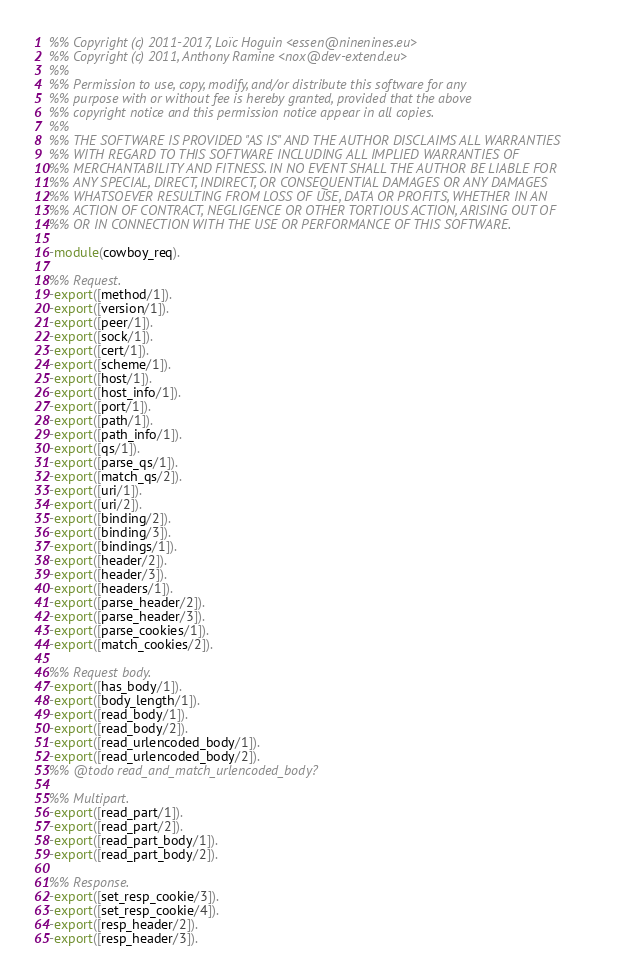<code> <loc_0><loc_0><loc_500><loc_500><_Erlang_>%% Copyright (c) 2011-2017, Loïc Hoguin <essen@ninenines.eu>
%% Copyright (c) 2011, Anthony Ramine <nox@dev-extend.eu>
%%
%% Permission to use, copy, modify, and/or distribute this software for any
%% purpose with or without fee is hereby granted, provided that the above
%% copyright notice and this permission notice appear in all copies.
%%
%% THE SOFTWARE IS PROVIDED "AS IS" AND THE AUTHOR DISCLAIMS ALL WARRANTIES
%% WITH REGARD TO THIS SOFTWARE INCLUDING ALL IMPLIED WARRANTIES OF
%% MERCHANTABILITY AND FITNESS. IN NO EVENT SHALL THE AUTHOR BE LIABLE FOR
%% ANY SPECIAL, DIRECT, INDIRECT, OR CONSEQUENTIAL DAMAGES OR ANY DAMAGES
%% WHATSOEVER RESULTING FROM LOSS OF USE, DATA OR PROFITS, WHETHER IN AN
%% ACTION OF CONTRACT, NEGLIGENCE OR OTHER TORTIOUS ACTION, ARISING OUT OF
%% OR IN CONNECTION WITH THE USE OR PERFORMANCE OF THIS SOFTWARE.

-module(cowboy_req).

%% Request.
-export([method/1]).
-export([version/1]).
-export([peer/1]).
-export([sock/1]).
-export([cert/1]).
-export([scheme/1]).
-export([host/1]).
-export([host_info/1]).
-export([port/1]).
-export([path/1]).
-export([path_info/1]).
-export([qs/1]).
-export([parse_qs/1]).
-export([match_qs/2]).
-export([uri/1]).
-export([uri/2]).
-export([binding/2]).
-export([binding/3]).
-export([bindings/1]).
-export([header/2]).
-export([header/3]).
-export([headers/1]).
-export([parse_header/2]).
-export([parse_header/3]).
-export([parse_cookies/1]).
-export([match_cookies/2]).

%% Request body.
-export([has_body/1]).
-export([body_length/1]).
-export([read_body/1]).
-export([read_body/2]).
-export([read_urlencoded_body/1]).
-export([read_urlencoded_body/2]).
%% @todo read_and_match_urlencoded_body?

%% Multipart.
-export([read_part/1]).
-export([read_part/2]).
-export([read_part_body/1]).
-export([read_part_body/2]).

%% Response.
-export([set_resp_cookie/3]).
-export([set_resp_cookie/4]).
-export([resp_header/2]).
-export([resp_header/3]).</code> 